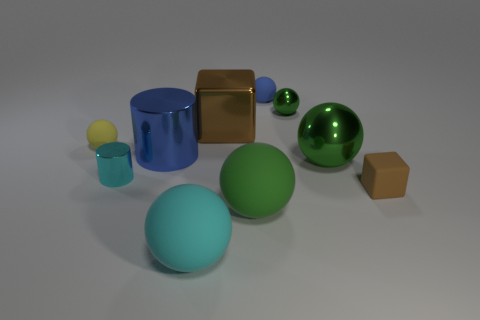How many green spheres must be subtracted to get 1 green spheres? 2 Subtract all gray cylinders. How many green spheres are left? 3 Subtract all cyan spheres. How many spheres are left? 5 Subtract all yellow spheres. How many spheres are left? 5 Subtract all red balls. Subtract all red cylinders. How many balls are left? 6 Subtract all spheres. How many objects are left? 4 Add 8 big green spheres. How many big green spheres exist? 10 Subtract 2 green spheres. How many objects are left? 8 Subtract all brown things. Subtract all small brown objects. How many objects are left? 7 Add 4 cyan metallic things. How many cyan metallic things are left? 5 